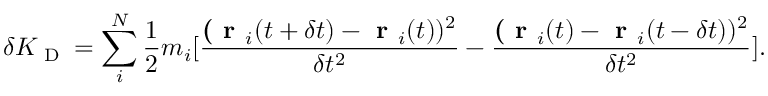Convert formula to latex. <formula><loc_0><loc_0><loc_500><loc_500>\delta K _ { D } = \sum _ { i } ^ { N } \frac { 1 } { 2 } m _ { i } [ \frac { ( r _ { i } ( t + \delta t ) - r _ { i } ( t ) ) ^ { 2 } } { \delta t ^ { 2 } } - \frac { ( r _ { i } ( t ) - r _ { i } ( t - \delta t ) ) ^ { 2 } } { \delta t ^ { 2 } } ] .</formula> 